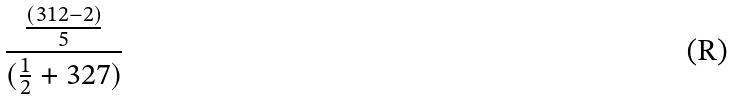<formula> <loc_0><loc_0><loc_500><loc_500>\frac { \frac { ( 3 1 2 - 2 ) } { 5 } } { ( \frac { 1 } { 2 } + 3 2 7 ) }</formula> 